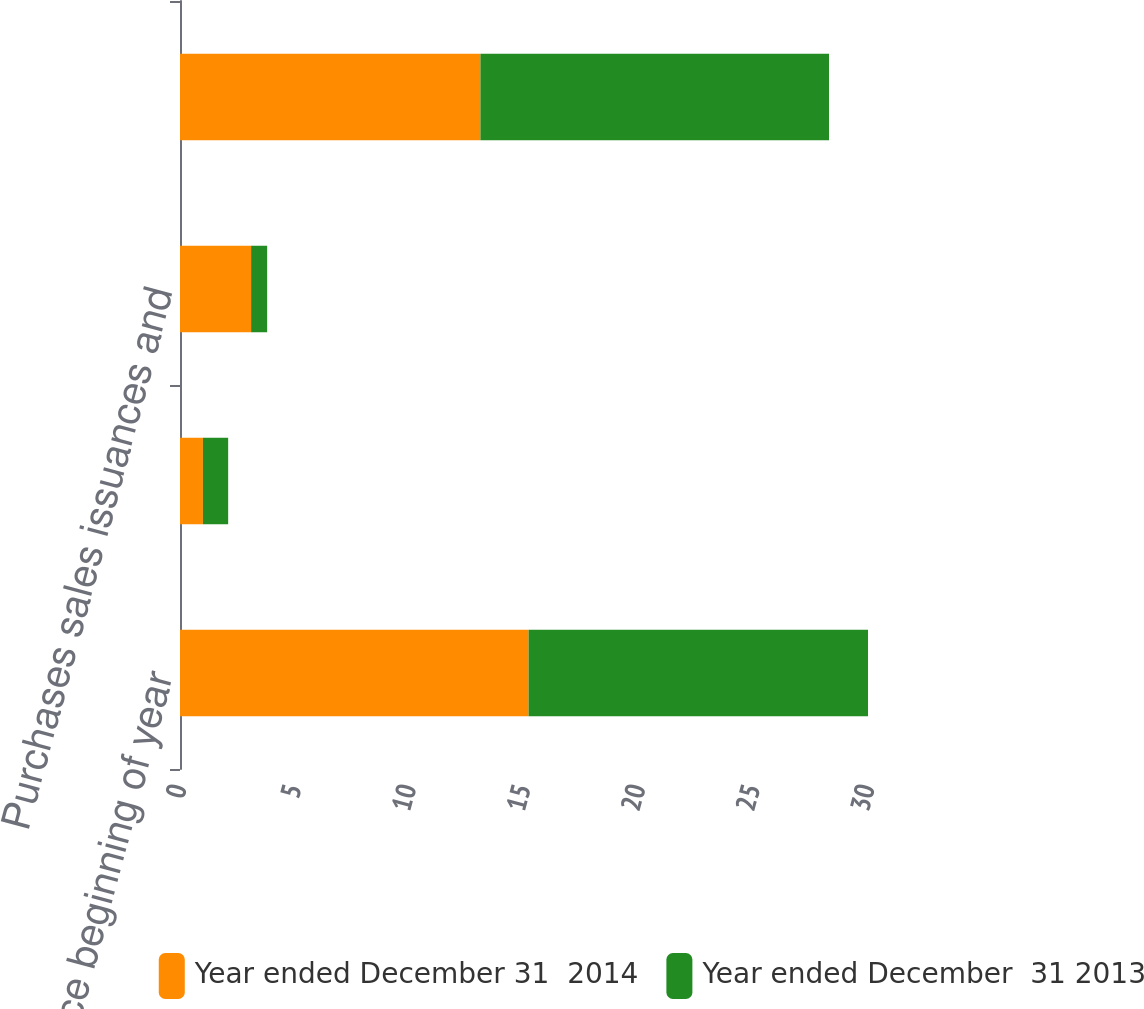Convert chart. <chart><loc_0><loc_0><loc_500><loc_500><stacked_bar_chart><ecel><fcel>Balance beginning of year<fcel>Unrealized gains/(losses)<fcel>Purchases sales issuances and<fcel>Balance end of year<nl><fcel>Year ended December 31  2014<fcel>15.2<fcel>1<fcel>3.1<fcel>13.1<nl><fcel>Year ended December  31 2013<fcel>14.8<fcel>1.1<fcel>0.7<fcel>15.2<nl></chart> 